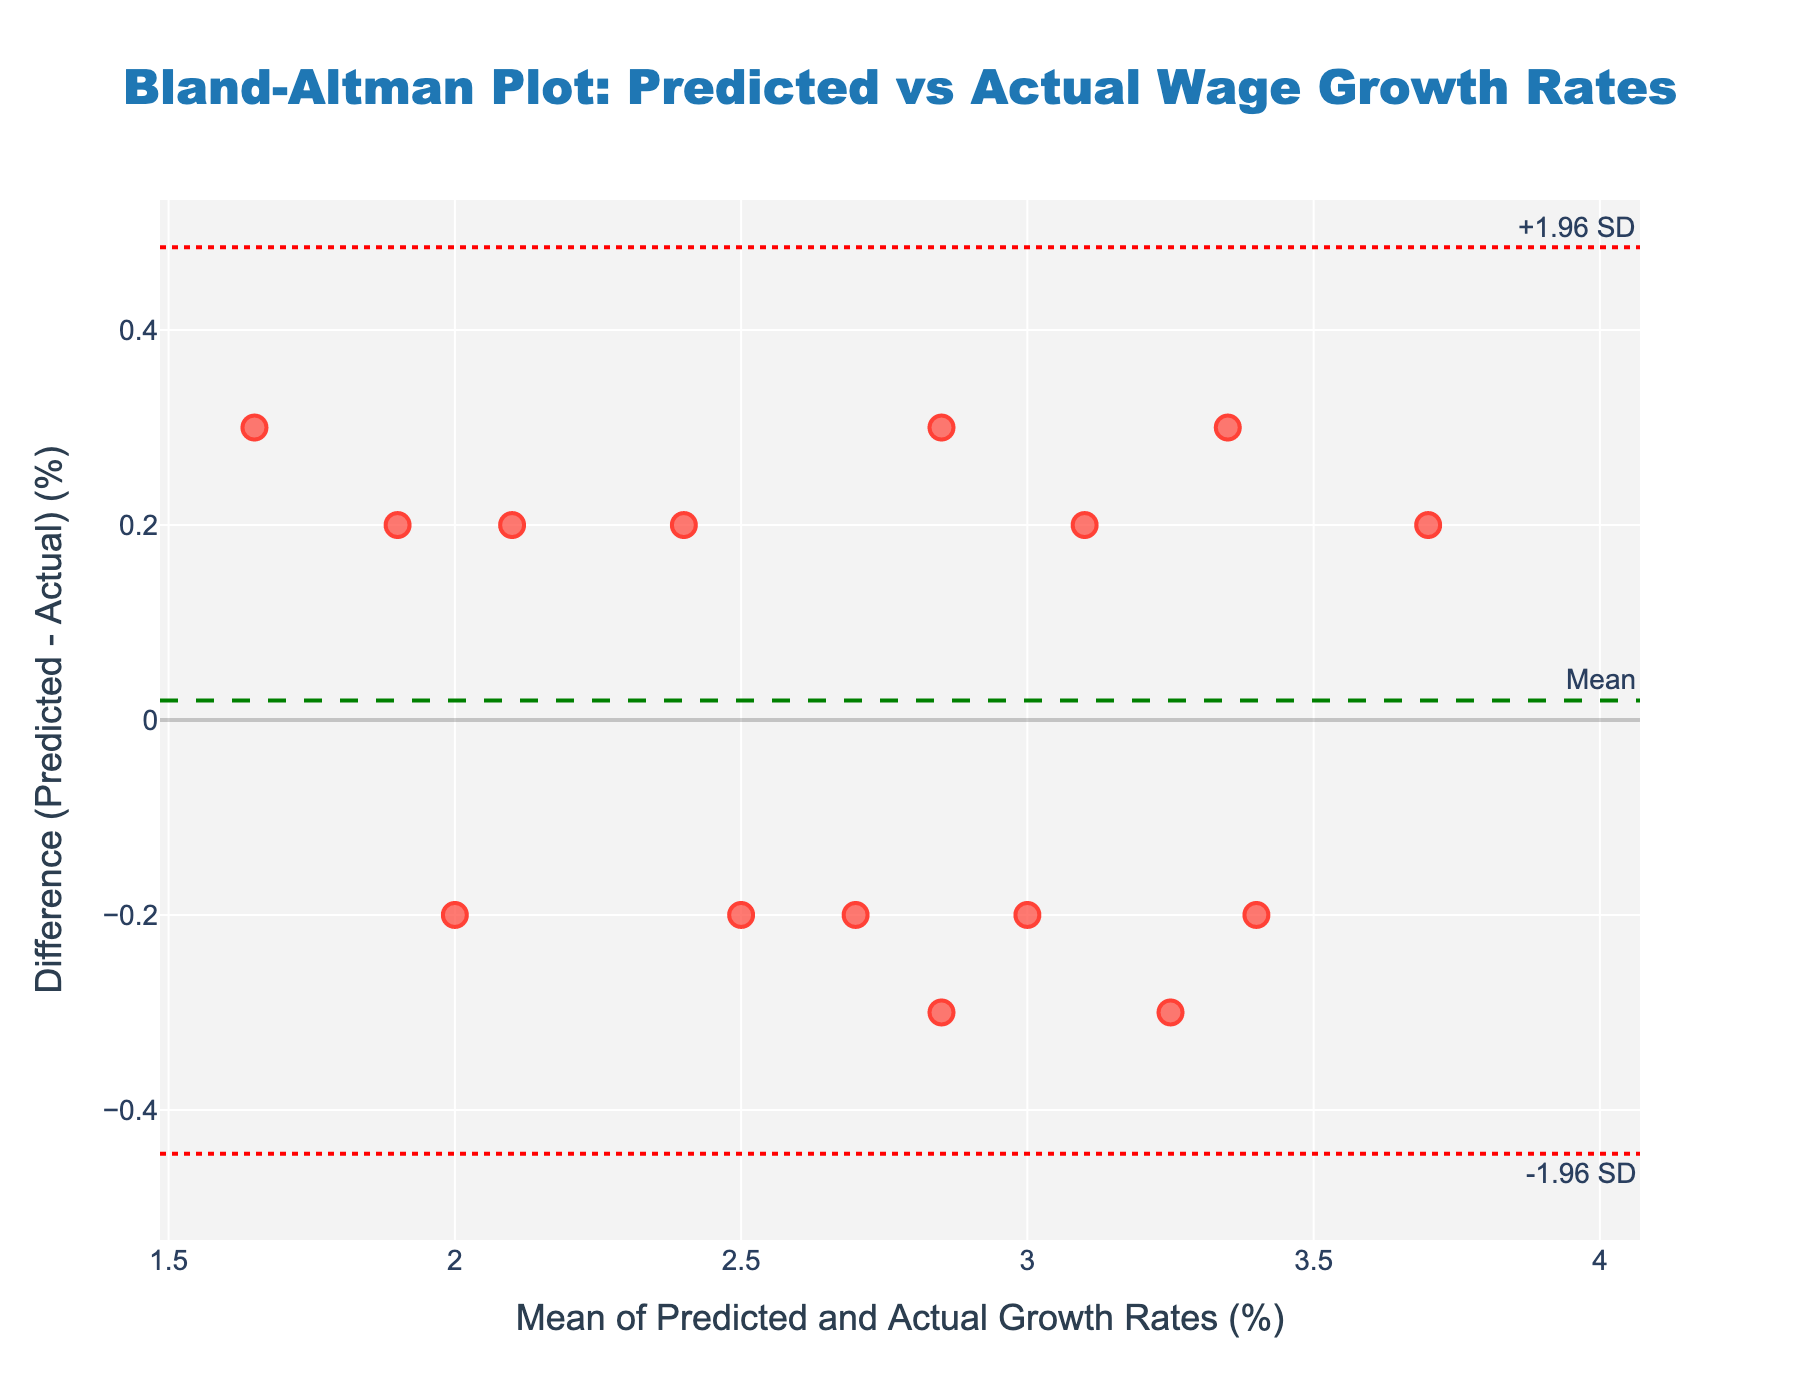what is the title of the plot? The title is located at the top center of the plot and provides a summary of what the figure represents. In this case, it reads "Bland-Altman Plot: Predicted vs Actual Wage Growth Rates."
Answer: Bland-Altman Plot: Predicted vs Actual Wage Growth Rates What does the y-axis represent? The y-axis label is given and it indicates that the y-axis represents the difference between Predicted and Actual Growth Rates expressed in percentage.
Answer: Difference (Predicted - Actual) (%) What is the mean difference between the predicted and actual growth rates? The green dashed line on the plot represents the mean difference, and the label "Mean" is positioned at the top right of this line.
Answer: Mean difference is 0% What are the limits of agreement on the plot? The plot has two red dot-dash lines that represent the limits of agreement, labeled "+1.96 SD" and "-1.96 SD." These are positioned at the top and bottom right of the respective lines.
Answer: Limits of agreement are approximately +0.37% and -0.37% How many data points are represented in the plot? By counting the red markers (scatter points), we can determine the number of data points. There are 15 data points shown in the plot.
Answer: There are 15 data points What's the range of mean growth rates in the plot? The x-axis represents the mean of the Predicted and Actual Growth Rates. By observing the minimum and maximum values along this axis, we can determine the range. The mean growth rates range from approximately 1.65% to 3.65%.
Answer: 1.65% to 3.65% Are there more data points with positive or negative differences? By visually inspecting the plot, count the markers above and below the mean difference line. There are more data points with positive differences than negative.
Answer: More points with positive differences Which data point shows the largest difference between predicted and actual growth rates? The point furthest from the mean difference line represents the largest difference. This point is around 1.9% difference, positioned near a mean of approximately 3.0%.
Answer: Point around mean 3.0% with 1.9% difference Is there a trend or pattern in the differences related to the mean of growth rates? Examine how the differences are scattered relative to the mean of growth rates. The differences appear randomly distributed without a clear increasing or decreasing pattern, indicating no clear trend.
Answer: No clear trend What can be inferred if a significant number of data points lie outside the limits of agreement? Points outside the limits of agreement suggest poor agreement between predicted and actual values; however, in this plot, no points lie outside these limits, indicating a good agreement.
Answer: Good agreement, no points outside the limits 